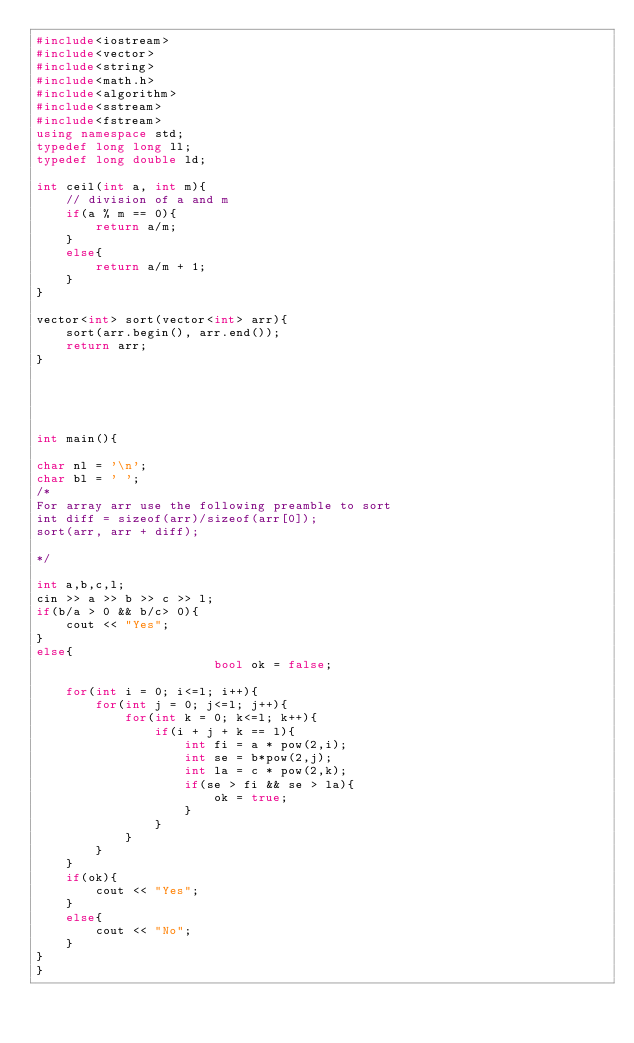Convert code to text. <code><loc_0><loc_0><loc_500><loc_500><_C++_>#include<iostream>
#include<vector>
#include<string>
#include<math.h> 
#include<algorithm> 
#include<sstream>
#include<fstream>  
using namespace std; 
typedef long long ll; 
typedef long double ld; 

int ceil(int a, int m){
    // division of a and m
    if(a % m == 0){
        return a/m; 
    }
    else{
        return a/m + 1; 
    }
}

vector<int> sort(vector<int> arr){
    sort(arr.begin(), arr.end()); 
    return arr; 
}





int main(){

char nl = '\n'; 
char bl = ' ';
/*
For array arr use the following preamble to sort
int diff = sizeof(arr)/sizeof(arr[0]); 
sort(arr, arr + diff); 

*/

int a,b,c,l; 
cin >> a >> b >> c >> l; 
if(b/a > 0 && b/c> 0){
    cout << "Yes"; 
}
else{
                        bool ok = false; 

    for(int i = 0; i<=l; i++){
        for(int j = 0; j<=l; j++){
            for(int k = 0; k<=l; k++){
                if(i + j + k == l){
                    int fi = a * pow(2,i); 
                    int se = b*pow(2,j); 
                    int la = c * pow(2,k); 
                    if(se > fi && se > la){
                        ok = true; 
                    }
                }
            }
        }
    }
    if(ok){
        cout << "Yes"; 
    }
    else{
        cout << "No"; 
    }
}
}</code> 